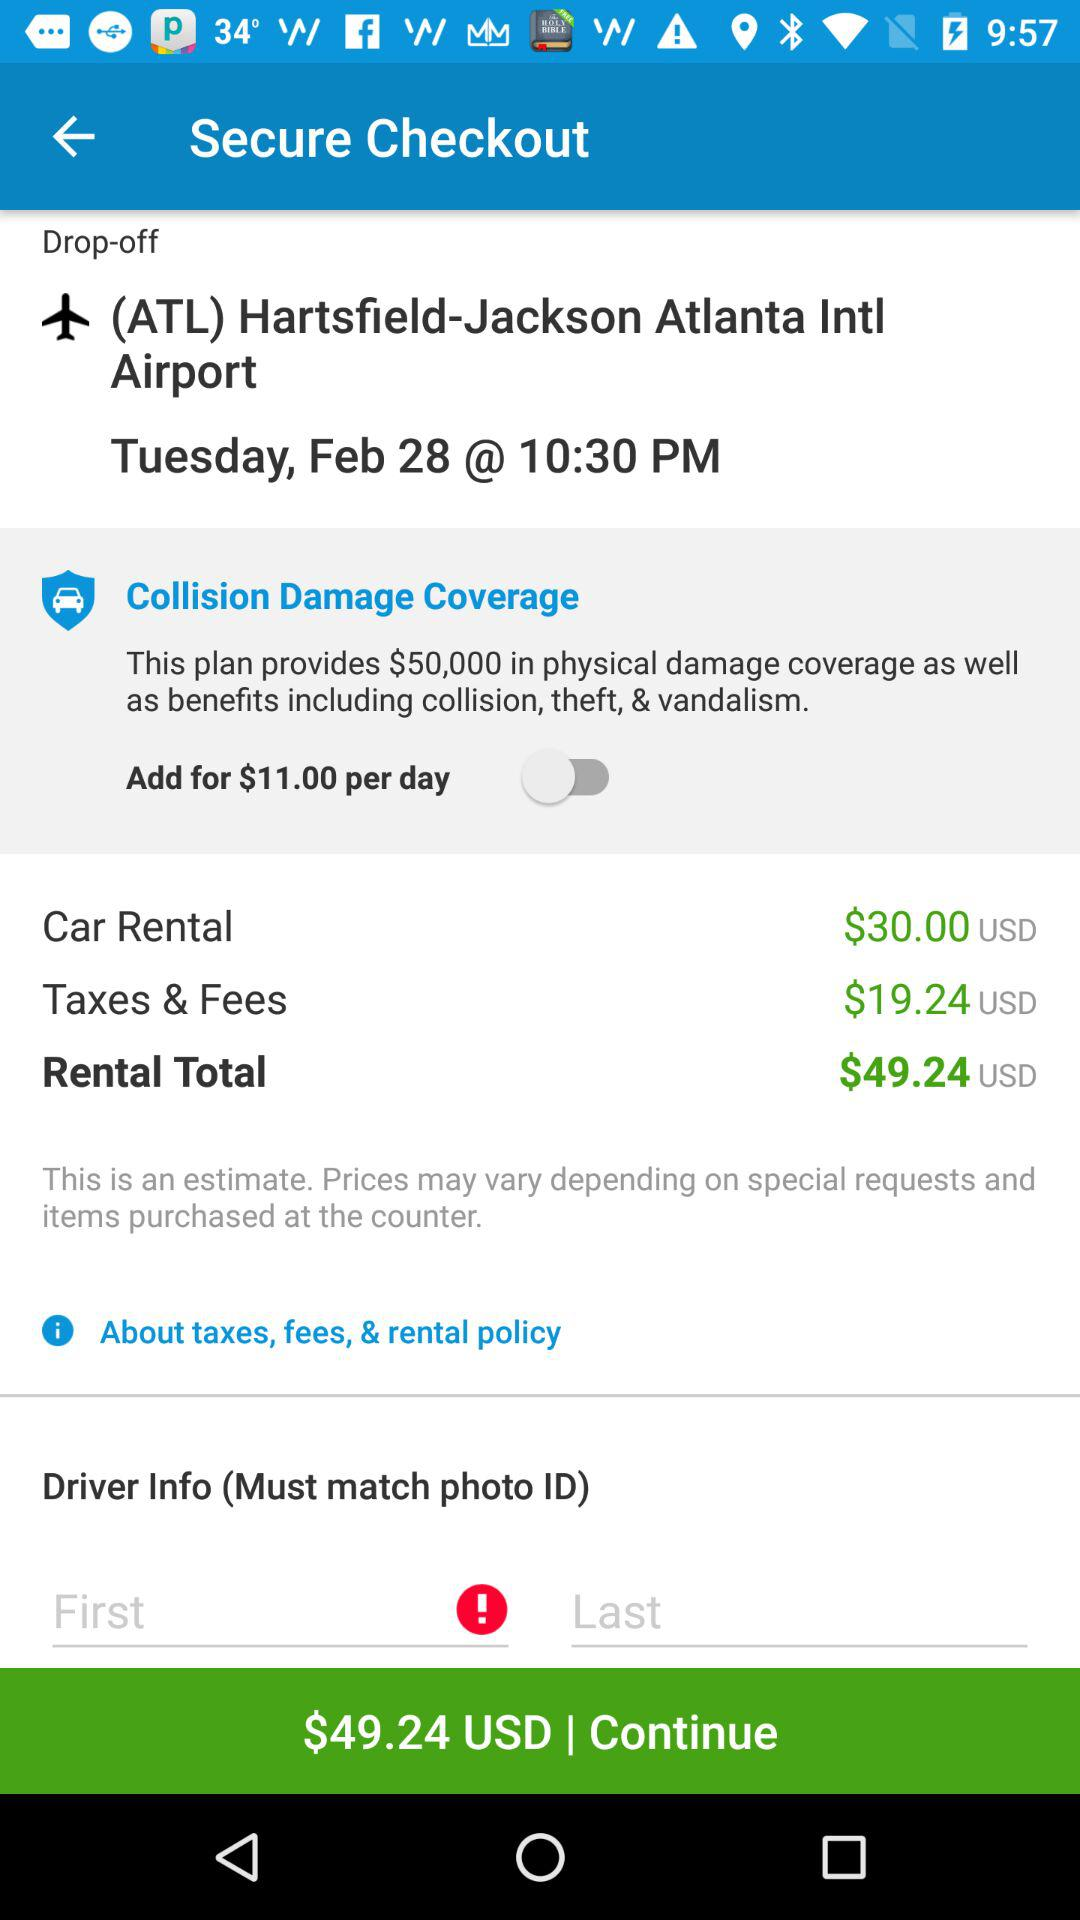What is the rental total? The rental total is 49.24 USD. 